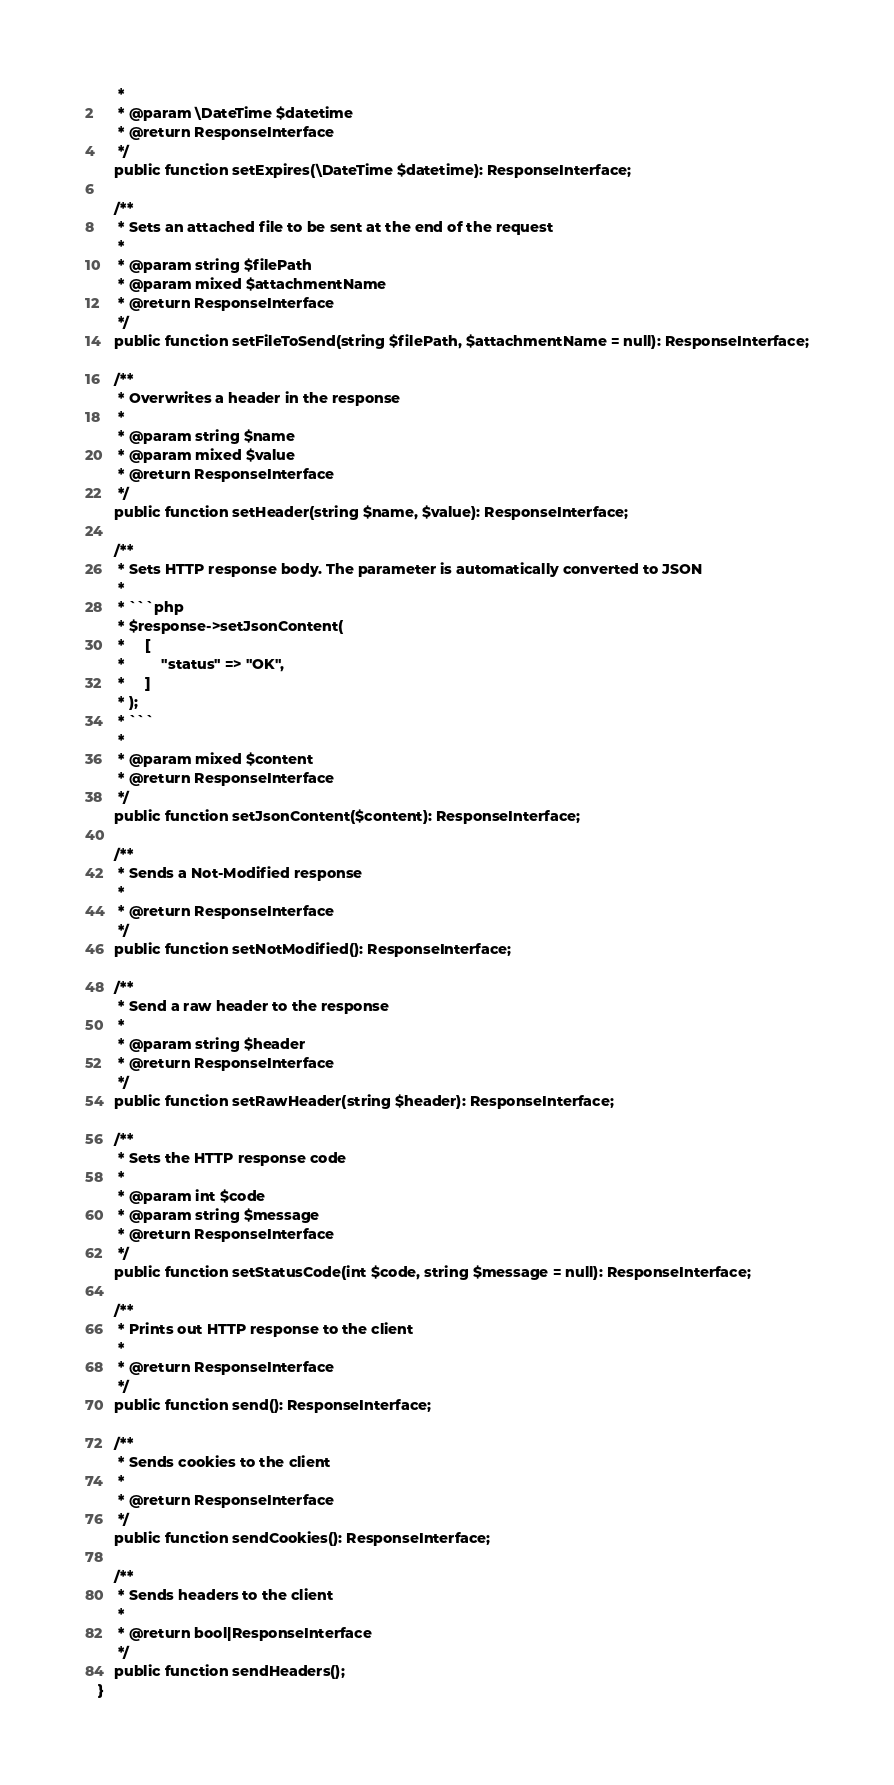Convert code to text. <code><loc_0><loc_0><loc_500><loc_500><_PHP_>     *
     * @param \DateTime $datetime
     * @return ResponseInterface
     */
    public function setExpires(\DateTime $datetime): ResponseInterface;

    /**
     * Sets an attached file to be sent at the end of the request
     *
     * @param string $filePath
     * @param mixed $attachmentName
     * @return ResponseInterface
     */
    public function setFileToSend(string $filePath, $attachmentName = null): ResponseInterface;

    /**
     * Overwrites a header in the response
     *
     * @param string $name
     * @param mixed $value
     * @return ResponseInterface
     */
    public function setHeader(string $name, $value): ResponseInterface;

    /**
     * Sets HTTP response body. The parameter is automatically converted to JSON
     *
     * ```php
     * $response->setJsonContent(
     *     [
     *         "status" => "OK",
     *     ]
     * );
     * ```
     *
     * @param mixed $content
     * @return ResponseInterface
     */
    public function setJsonContent($content): ResponseInterface;

    /**
     * Sends a Not-Modified response
     *
     * @return ResponseInterface
     */
    public function setNotModified(): ResponseInterface;

    /**
     * Send a raw header to the response
     *
     * @param string $header
     * @return ResponseInterface
     */
    public function setRawHeader(string $header): ResponseInterface;

    /**
     * Sets the HTTP response code
     *
     * @param int $code
     * @param string $message
     * @return ResponseInterface
     */
    public function setStatusCode(int $code, string $message = null): ResponseInterface;

    /**
     * Prints out HTTP response to the client
     *
     * @return ResponseInterface
     */
    public function send(): ResponseInterface;

    /**
     * Sends cookies to the client
     *
     * @return ResponseInterface
     */
    public function sendCookies(): ResponseInterface;

    /**
     * Sends headers to the client
     *
     * @return bool|ResponseInterface
     */
    public function sendHeaders();
}
</code> 